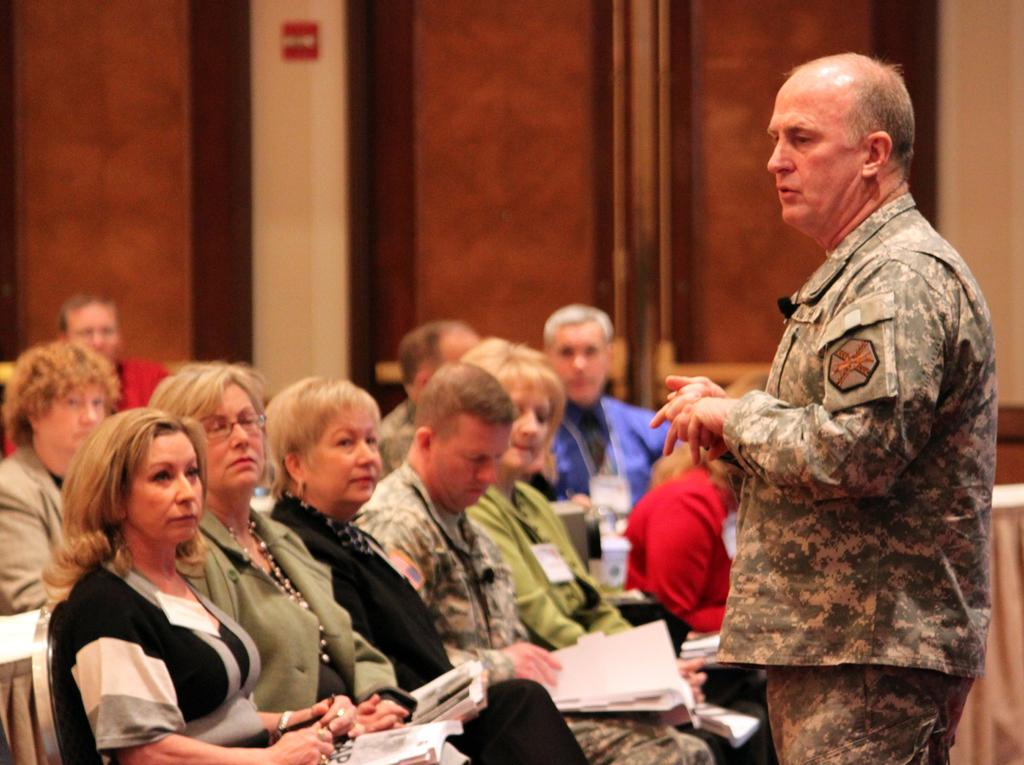What are the persons in the image doing? The persons in the image are sitting on chairs and holding books in their hands. Can you describe the man on the right side of the image? The man on the right side of the image appears to be speaking. What type of flag is being waved by the person in the image? There is no flag present in the image. What is the cause of the crack in the book being held by the person in the image? There is no crack in the book being held by the person in the image. 